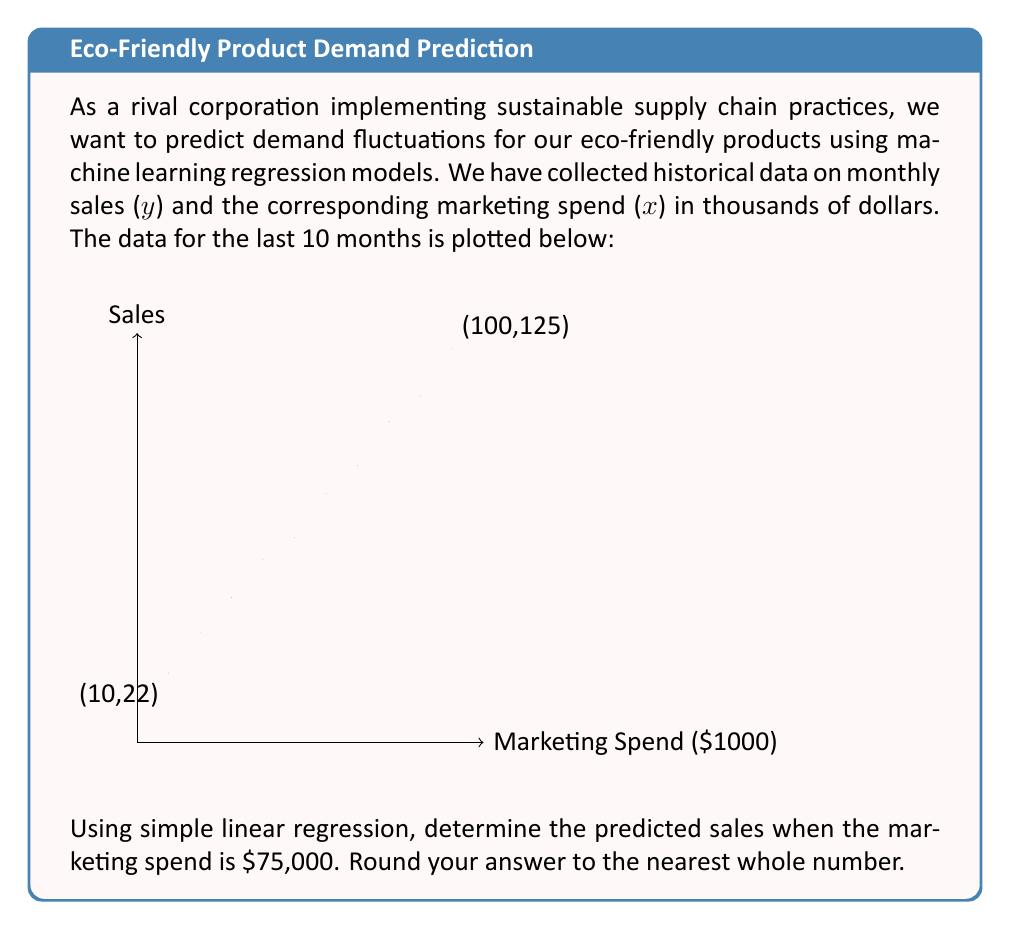Solve this math problem. To solve this problem, we'll use simple linear regression to model the relationship between marketing spend and sales. The steps are as follows:

1) The simple linear regression model is of the form:
   $$y = \beta_0 + \beta_1x$$
   where $\beta_0$ is the y-intercept and $\beta_1$ is the slope.

2) To find $\beta_0$ and $\beta_1$, we use the following formulas:
   $$\beta_1 = \frac{n\sum xy - \sum x \sum y}{n\sum x^2 - (\sum x)^2}$$
   $$\beta_0 = \bar{y} - \beta_1\bar{x}$$

3) From the data points, we can calculate:
   $n = 10$
   $\sum x = 550$
   $\sum y = 730$
   $\sum xy = 54,700$
   $\sum x^2 = 38,500$
   $\bar{x} = 55$
   $\bar{y} = 73$

4) Plugging these values into the formula for $\beta_1$:
   $$\beta_1 = \frac{10(54,700) - 550(730)}{10(38,500) - 550^2} = \frac{547,000 - 401,500}{385,000 - 302,500} = \frac{145,500}{82,500} = 1.1636$$

5) Now we can calculate $\beta_0$:
   $$\beta_0 = 73 - 1.1636(55) = 8.9982$$

6) Our regression equation is therefore:
   $$y = 8.9982 + 1.1636x$$

7) To predict sales when marketing spend is $75,000, we substitute x = 75:
   $$y = 8.9982 + 1.1636(75) = 96.2682$$

8) Rounding to the nearest whole number, we get 96.
Answer: 96 